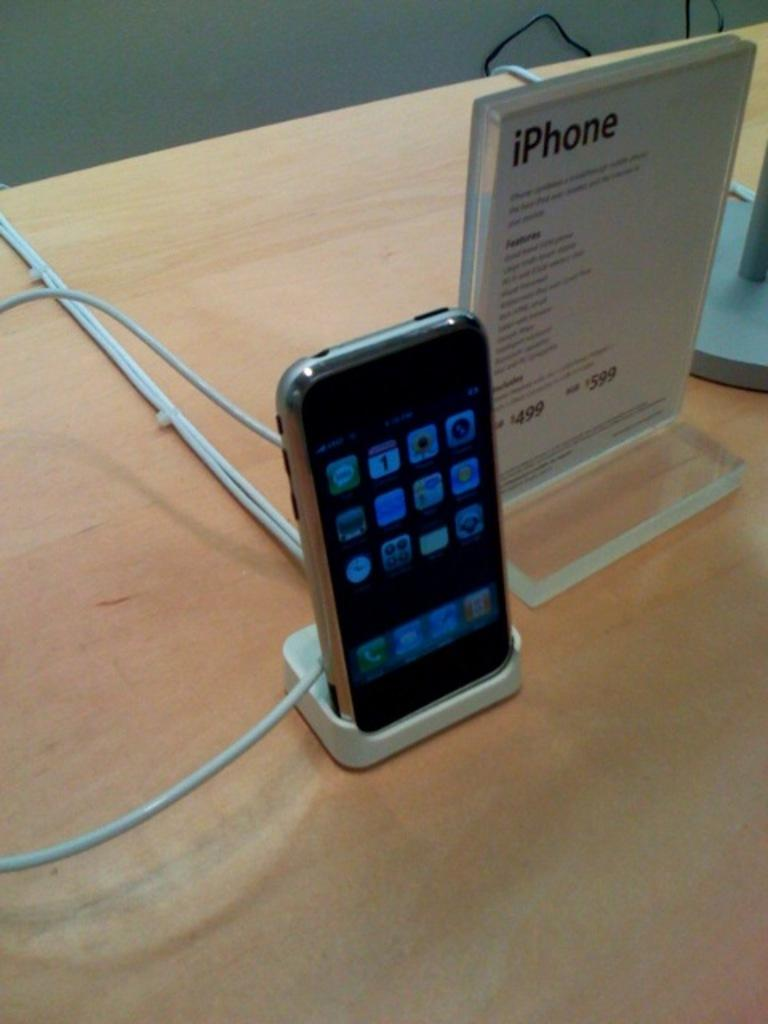<image>
Render a clear and concise summary of the photo. A sign for an iPhone sits next to a phone on display. 